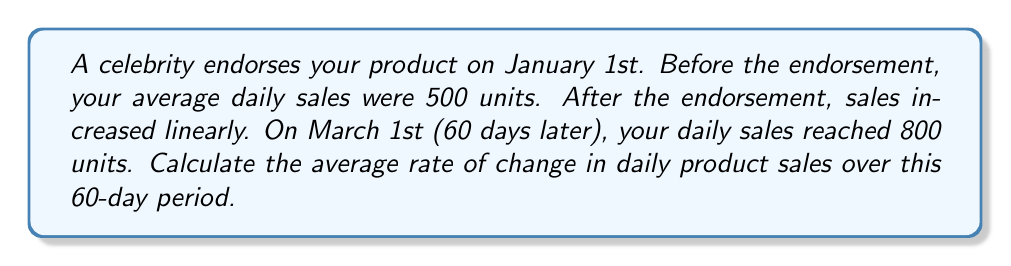Provide a solution to this math problem. To solve this problem, we need to use the average rate of change formula:

$$\text{Average rate of change} = \frac{\text{Change in y}}{\text{Change in x}}$$

Let's identify our variables:
- $x$ represents time in days
- $y$ represents daily sales

We have two points:
1. $(x_1, y_1) = (0, 500)$ (January 1st, initial sales)
2. $(x_2, y_2) = (60, 800)$ (March 1st, final sales)

Now, let's plug these into our formula:

$$\text{Average rate of change} = \frac{y_2 - y_1}{x_2 - x_1} = \frac{800 - 500}{60 - 0}$$

Simplifying:

$$\frac{300}{60} = 5$$

This means that, on average, daily sales increased by 5 units per day over the 60-day period.
Answer: The average rate of change in daily product sales over the 60-day period is 5 units per day. 